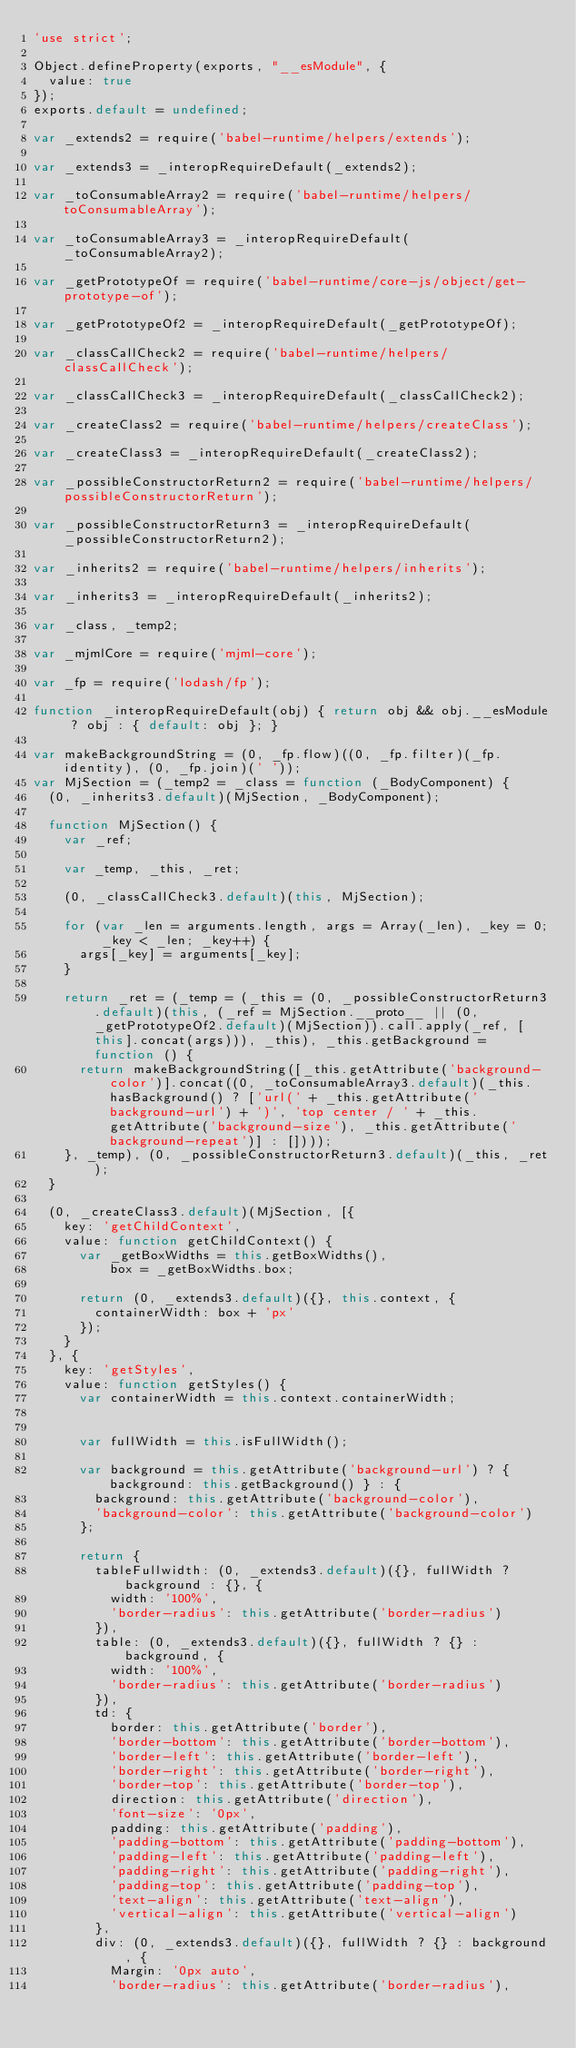Convert code to text. <code><loc_0><loc_0><loc_500><loc_500><_JavaScript_>'use strict';

Object.defineProperty(exports, "__esModule", {
  value: true
});
exports.default = undefined;

var _extends2 = require('babel-runtime/helpers/extends');

var _extends3 = _interopRequireDefault(_extends2);

var _toConsumableArray2 = require('babel-runtime/helpers/toConsumableArray');

var _toConsumableArray3 = _interopRequireDefault(_toConsumableArray2);

var _getPrototypeOf = require('babel-runtime/core-js/object/get-prototype-of');

var _getPrototypeOf2 = _interopRequireDefault(_getPrototypeOf);

var _classCallCheck2 = require('babel-runtime/helpers/classCallCheck');

var _classCallCheck3 = _interopRequireDefault(_classCallCheck2);

var _createClass2 = require('babel-runtime/helpers/createClass');

var _createClass3 = _interopRequireDefault(_createClass2);

var _possibleConstructorReturn2 = require('babel-runtime/helpers/possibleConstructorReturn');

var _possibleConstructorReturn3 = _interopRequireDefault(_possibleConstructorReturn2);

var _inherits2 = require('babel-runtime/helpers/inherits');

var _inherits3 = _interopRequireDefault(_inherits2);

var _class, _temp2;

var _mjmlCore = require('mjml-core');

var _fp = require('lodash/fp');

function _interopRequireDefault(obj) { return obj && obj.__esModule ? obj : { default: obj }; }

var makeBackgroundString = (0, _fp.flow)((0, _fp.filter)(_fp.identity), (0, _fp.join)(' '));
var MjSection = (_temp2 = _class = function (_BodyComponent) {
  (0, _inherits3.default)(MjSection, _BodyComponent);

  function MjSection() {
    var _ref;

    var _temp, _this, _ret;

    (0, _classCallCheck3.default)(this, MjSection);

    for (var _len = arguments.length, args = Array(_len), _key = 0; _key < _len; _key++) {
      args[_key] = arguments[_key];
    }

    return _ret = (_temp = (_this = (0, _possibleConstructorReturn3.default)(this, (_ref = MjSection.__proto__ || (0, _getPrototypeOf2.default)(MjSection)).call.apply(_ref, [this].concat(args))), _this), _this.getBackground = function () {
      return makeBackgroundString([_this.getAttribute('background-color')].concat((0, _toConsumableArray3.default)(_this.hasBackground() ? ['url(' + _this.getAttribute('background-url') + ')', 'top center / ' + _this.getAttribute('background-size'), _this.getAttribute('background-repeat')] : [])));
    }, _temp), (0, _possibleConstructorReturn3.default)(_this, _ret);
  }

  (0, _createClass3.default)(MjSection, [{
    key: 'getChildContext',
    value: function getChildContext() {
      var _getBoxWidths = this.getBoxWidths(),
          box = _getBoxWidths.box;

      return (0, _extends3.default)({}, this.context, {
        containerWidth: box + 'px'
      });
    }
  }, {
    key: 'getStyles',
    value: function getStyles() {
      var containerWidth = this.context.containerWidth;


      var fullWidth = this.isFullWidth();

      var background = this.getAttribute('background-url') ? { background: this.getBackground() } : {
        background: this.getAttribute('background-color'),
        'background-color': this.getAttribute('background-color')
      };

      return {
        tableFullwidth: (0, _extends3.default)({}, fullWidth ? background : {}, {
          width: '100%',
          'border-radius': this.getAttribute('border-radius')
        }),
        table: (0, _extends3.default)({}, fullWidth ? {} : background, {
          width: '100%',
          'border-radius': this.getAttribute('border-radius')
        }),
        td: {
          border: this.getAttribute('border'),
          'border-bottom': this.getAttribute('border-bottom'),
          'border-left': this.getAttribute('border-left'),
          'border-right': this.getAttribute('border-right'),
          'border-top': this.getAttribute('border-top'),
          direction: this.getAttribute('direction'),
          'font-size': '0px',
          padding: this.getAttribute('padding'),
          'padding-bottom': this.getAttribute('padding-bottom'),
          'padding-left': this.getAttribute('padding-left'),
          'padding-right': this.getAttribute('padding-right'),
          'padding-top': this.getAttribute('padding-top'),
          'text-align': this.getAttribute('text-align'),
          'vertical-align': this.getAttribute('vertical-align')
        },
        div: (0, _extends3.default)({}, fullWidth ? {} : background, {
          Margin: '0px auto',
          'border-radius': this.getAttribute('border-radius'),</code> 